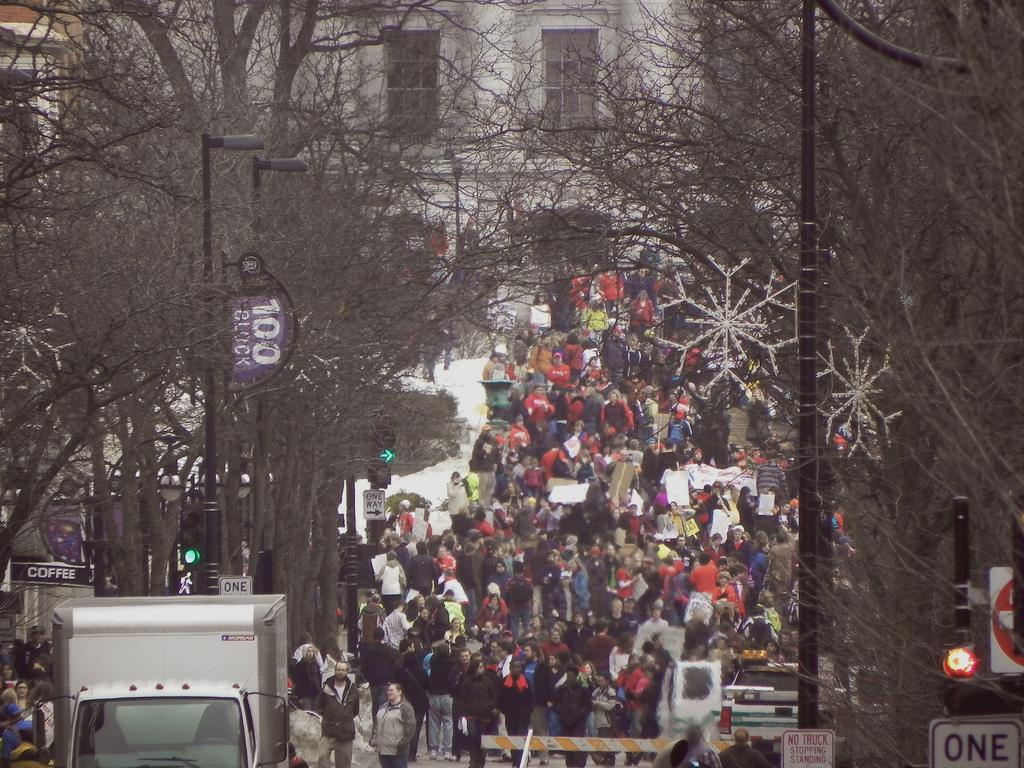How many people are in the group visible in the image? There is a group of people in the image, but the exact number cannot be determined from the provided facts. What type of vehicles can be seen on the road in the image? Vehicles are present on the road in the image, but their specific types cannot be determined from the provided facts. What is written on the signboard in the image? The content of the signboard cannot be determined from the provided facts. What is the purpose of the street lights in the background of the image? The street lights in the background of the image are likely for illumination purposes, but their specific function cannot be determined from the provided facts. What type of buildings are in the background of the image? Buildings are present in the background of the image, but their specific types cannot be determined from the provided facts. Can you see a maid carrying a twig in the image? There is no mention of a maid or a twig in the provided facts, so it cannot be determined if they are present in the image. 